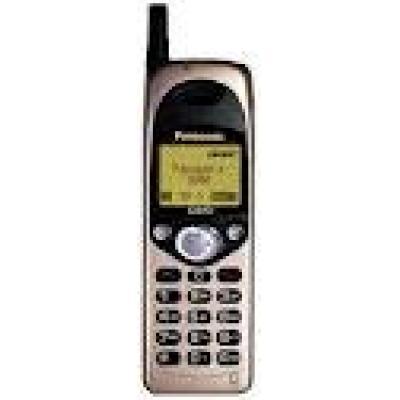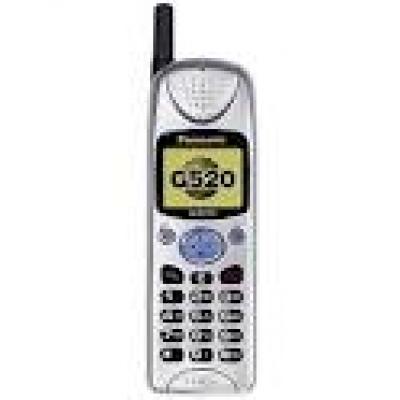The first image is the image on the left, the second image is the image on the right. Considering the images on both sides, is "In at least one image the is a single phone with a clear but blue button  in the middle of the phone representing 4 arrow keys." valid? Answer yes or no. Yes. The first image is the image on the left, the second image is the image on the right. For the images shown, is this caption "Each image contains one narrow rectangular phone displayed vertically, with an antenna projecting from the top left of the phone." true? Answer yes or no. Yes. 